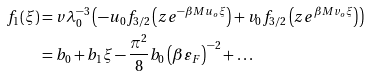<formula> <loc_0><loc_0><loc_500><loc_500>f _ { 1 } ( \xi ) & = v \lambda _ { 0 } ^ { - 3 } \left ( - u _ { 0 } f _ { 3 / 2 } \left ( z e ^ { - \beta M u _ { o } \xi } \right ) + v _ { 0 } f _ { 3 / 2 } \left ( z e ^ { \beta M v _ { o } \xi } \right ) \right ) \\ & = b _ { 0 } + b _ { 1 } \xi - \frac { \pi ^ { 2 } } { 8 } b _ { 0 } \left ( \beta \varepsilon _ { F } \right ) ^ { - 2 } + \dots \\</formula> 